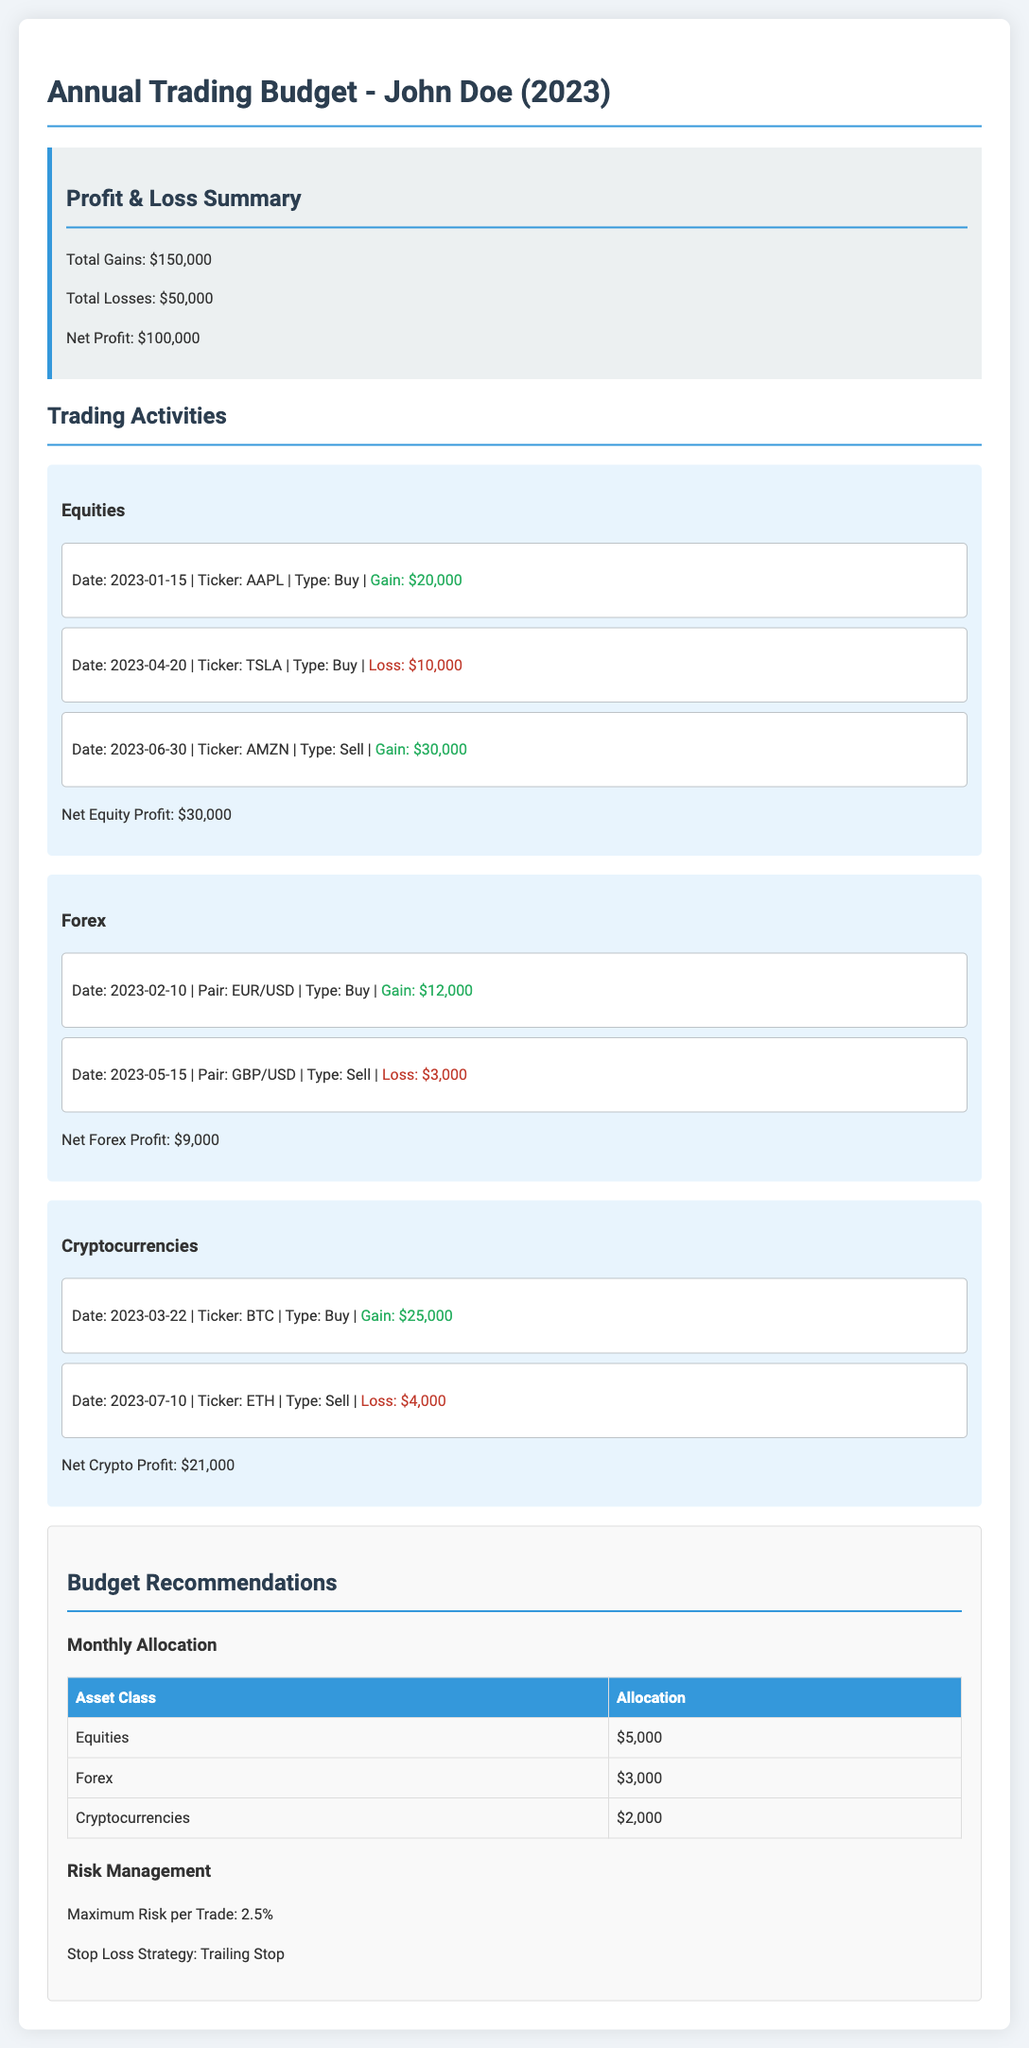What is the net profit for the year? The net profit is calculated by taking total gains minus total losses, which equals $150,000 - $50,000.
Answer: $100,000 What was the gain from the AAPL trade? The gain from the AAPL trade is mentioned in the document, which shows a gain of $20,000.
Answer: $20,000 What is the loss incurred from the TSLA trade? The loss incurred from the TSLA trade is presented in the document as a loss of $10,000.
Answer: $10,000 What is the monthly allocation for Forex? The document specifies the monthly allocation for Forex as $3,000.
Answer: $3,000 What is the total loss for the trading year? Total losses are specified in the budget as $50,000.
Answer: $50,000 Which asset class had the highest net profit? By comparing the net profits of each asset class, the highest net profit comes from Equities, which totals $30,000.
Answer: Equities What percentage is designated as the maximum risk per trade? The document states that the maximum risk per trade is set at 2.5%.
Answer: 2.5% What was the gain from the BTC trade? The gain from the BTC trade is documented as $25,000.
Answer: $25,000 What is the stop-loss strategy mentioned in the budget? The strategy outlined in the document for stop-loss management is a trailing stop.
Answer: Trailing Stop 